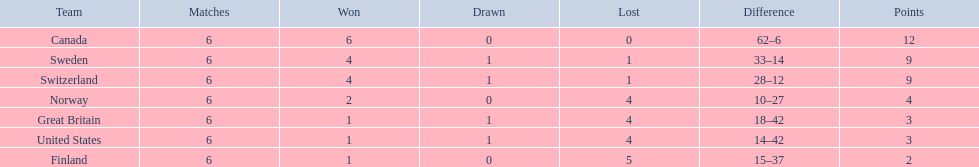During the 1951 world ice hockey championships, what was the difference between the first and last place teams for number of games won ? 5. 